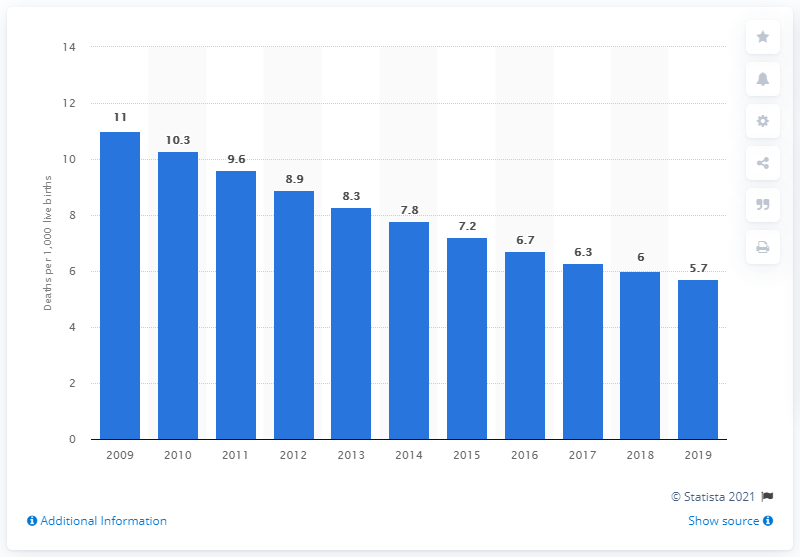Mention a couple of crucial points in this snapshot. In 2019, the infant mortality rate in Saudi Arabia was 5.7, indicating a continued improvement in the health and well-being of the country's youngest citizens. 